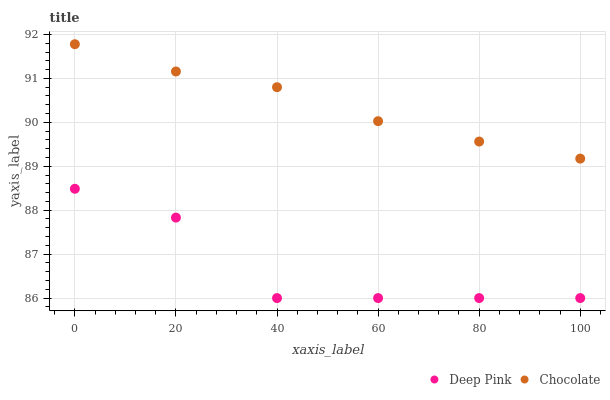Does Deep Pink have the minimum area under the curve?
Answer yes or no. Yes. Does Chocolate have the maximum area under the curve?
Answer yes or no. Yes. Does Chocolate have the minimum area under the curve?
Answer yes or no. No. Is Chocolate the smoothest?
Answer yes or no. Yes. Is Deep Pink the roughest?
Answer yes or no. Yes. Is Chocolate the roughest?
Answer yes or no. No. Does Deep Pink have the lowest value?
Answer yes or no. Yes. Does Chocolate have the lowest value?
Answer yes or no. No. Does Chocolate have the highest value?
Answer yes or no. Yes. Is Deep Pink less than Chocolate?
Answer yes or no. Yes. Is Chocolate greater than Deep Pink?
Answer yes or no. Yes. Does Deep Pink intersect Chocolate?
Answer yes or no. No. 